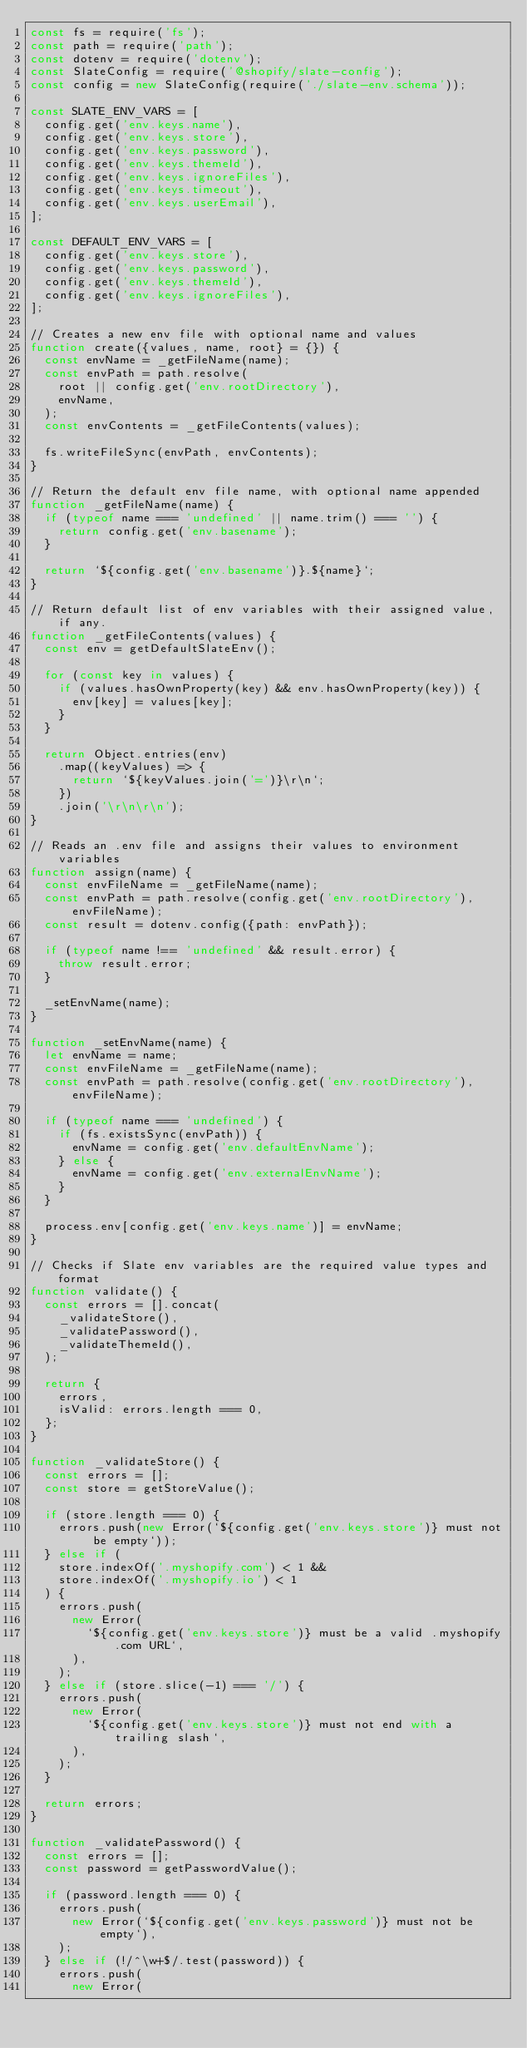<code> <loc_0><loc_0><loc_500><loc_500><_JavaScript_>const fs = require('fs');
const path = require('path');
const dotenv = require('dotenv');
const SlateConfig = require('@shopify/slate-config');
const config = new SlateConfig(require('./slate-env.schema'));

const SLATE_ENV_VARS = [
  config.get('env.keys.name'),
  config.get('env.keys.store'),
  config.get('env.keys.password'),
  config.get('env.keys.themeId'),
  config.get('env.keys.ignoreFiles'),
  config.get('env.keys.timeout'),
  config.get('env.keys.userEmail'),
];

const DEFAULT_ENV_VARS = [
  config.get('env.keys.store'),
  config.get('env.keys.password'),
  config.get('env.keys.themeId'),
  config.get('env.keys.ignoreFiles'),
];

// Creates a new env file with optional name and values
function create({values, name, root} = {}) {
  const envName = _getFileName(name);
  const envPath = path.resolve(
    root || config.get('env.rootDirectory'),
    envName,
  );
  const envContents = _getFileContents(values);

  fs.writeFileSync(envPath, envContents);
}

// Return the default env file name, with optional name appended
function _getFileName(name) {
  if (typeof name === 'undefined' || name.trim() === '') {
    return config.get('env.basename');
  }

  return `${config.get('env.basename')}.${name}`;
}

// Return default list of env variables with their assigned value, if any.
function _getFileContents(values) {
  const env = getDefaultSlateEnv();

  for (const key in values) {
    if (values.hasOwnProperty(key) && env.hasOwnProperty(key)) {
      env[key] = values[key];
    }
  }

  return Object.entries(env)
    .map((keyValues) => {
      return `${keyValues.join('=')}\r\n`;
    })
    .join('\r\n\r\n');
}

// Reads an .env file and assigns their values to environment variables
function assign(name) {
  const envFileName = _getFileName(name);
  const envPath = path.resolve(config.get('env.rootDirectory'), envFileName);
  const result = dotenv.config({path: envPath});

  if (typeof name !== 'undefined' && result.error) {
    throw result.error;
  }

  _setEnvName(name);
}

function _setEnvName(name) {
  let envName = name;
  const envFileName = _getFileName(name);
  const envPath = path.resolve(config.get('env.rootDirectory'), envFileName);

  if (typeof name === 'undefined') {
    if (fs.existsSync(envPath)) {
      envName = config.get('env.defaultEnvName');
    } else {
      envName = config.get('env.externalEnvName');
    }
  }

  process.env[config.get('env.keys.name')] = envName;
}

// Checks if Slate env variables are the required value types and format
function validate() {
  const errors = [].concat(
    _validateStore(),
    _validatePassword(),
    _validateThemeId(),
  );

  return {
    errors,
    isValid: errors.length === 0,
  };
}

function _validateStore() {
  const errors = [];
  const store = getStoreValue();

  if (store.length === 0) {
    errors.push(new Error(`${config.get('env.keys.store')} must not be empty`));
  } else if (
    store.indexOf('.myshopify.com') < 1 &&
    store.indexOf('.myshopify.io') < 1
  ) {
    errors.push(
      new Error(
        `${config.get('env.keys.store')} must be a valid .myshopify.com URL`,
      ),
    );
  } else if (store.slice(-1) === '/') {
    errors.push(
      new Error(
        `${config.get('env.keys.store')} must not end with a trailing slash`,
      ),
    );
  }

  return errors;
}

function _validatePassword() {
  const errors = [];
  const password = getPasswordValue();

  if (password.length === 0) {
    errors.push(
      new Error(`${config.get('env.keys.password')} must not be empty`),
    );
  } else if (!/^\w+$/.test(password)) {
    errors.push(
      new Error(</code> 